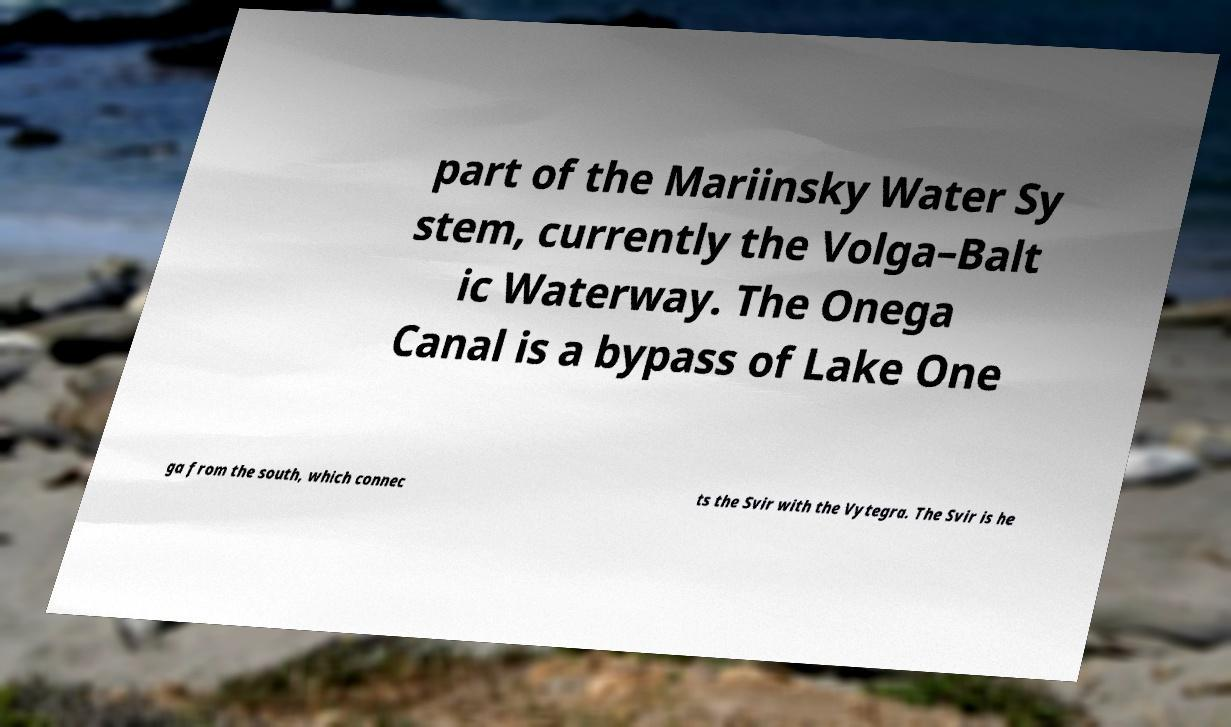Please read and relay the text visible in this image. What does it say? part of the Mariinsky Water Sy stem, currently the Volga–Balt ic Waterway. The Onega Canal is a bypass of Lake One ga from the south, which connec ts the Svir with the Vytegra. The Svir is he 